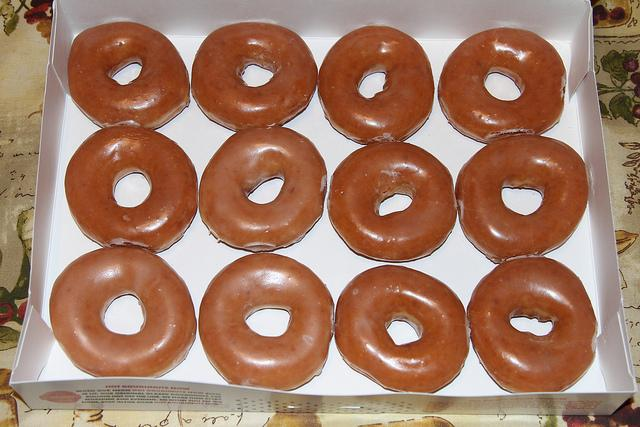What type of coating is found on the paper below the donuts? glaze 